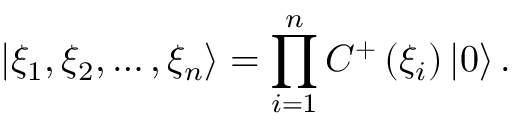<formula> <loc_0><loc_0><loc_500><loc_500>\left | \xi _ { 1 } , \xi _ { 2 } , \dots , \xi _ { n } \right \rangle = \prod _ { i = 1 } ^ { n } C ^ { + } \left ( \xi _ { i } \right ) \left | 0 \right \rangle .</formula> 